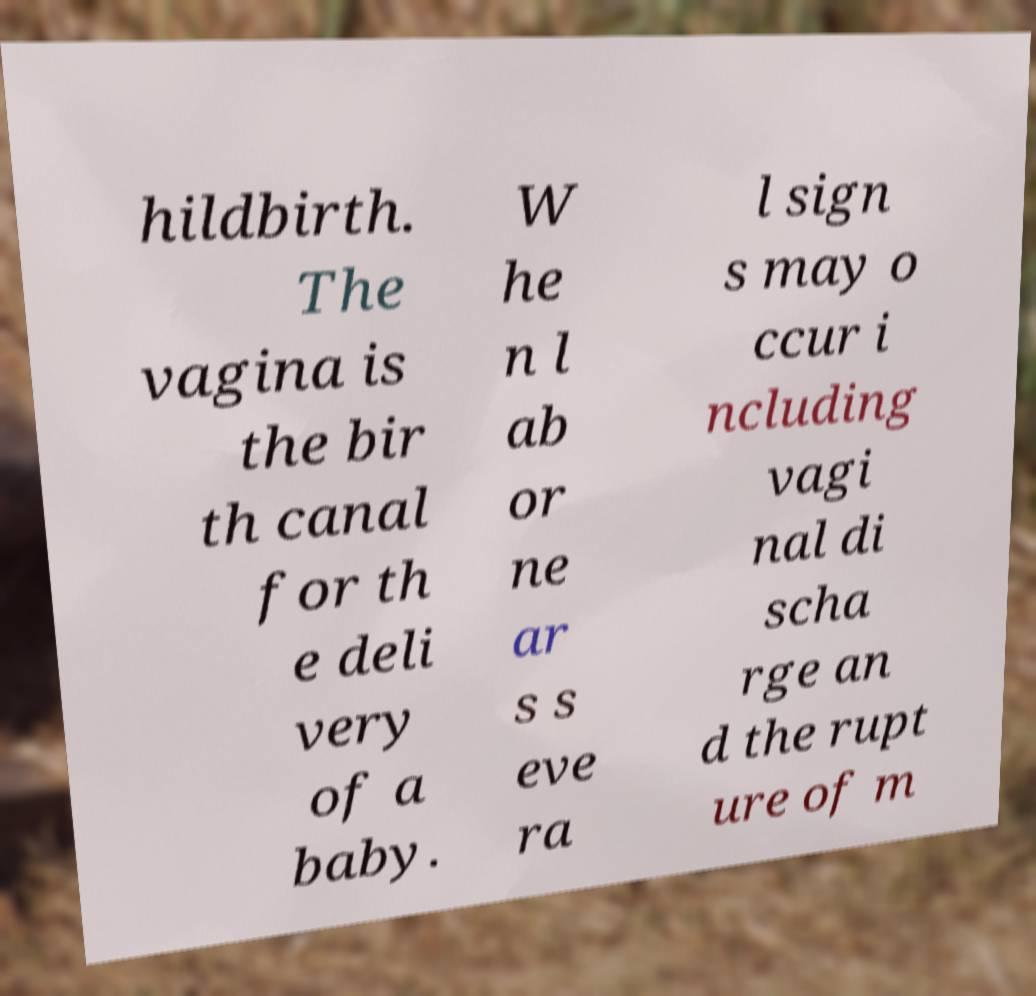What messages or text are displayed in this image? I need them in a readable, typed format. hildbirth. The vagina is the bir th canal for th e deli very of a baby. W he n l ab or ne ar s s eve ra l sign s may o ccur i ncluding vagi nal di scha rge an d the rupt ure of m 